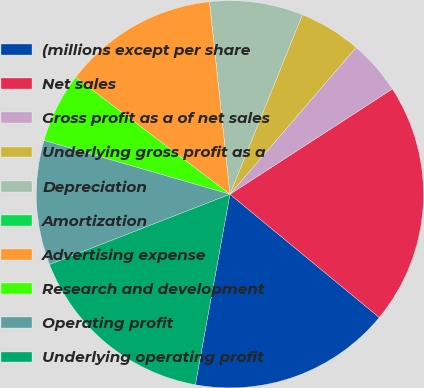Convert chart to OTSL. <chart><loc_0><loc_0><loc_500><loc_500><pie_chart><fcel>(millions except per share<fcel>Net sales<fcel>Gross profit as a of net sales<fcel>Underlying gross profit as a<fcel>Depreciation<fcel>Amortization<fcel>Advertising expense<fcel>Research and development<fcel>Operating profit<fcel>Underlying operating profit<nl><fcel>16.88%<fcel>20.13%<fcel>4.55%<fcel>5.19%<fcel>7.79%<fcel>0.0%<fcel>12.99%<fcel>5.84%<fcel>10.39%<fcel>16.23%<nl></chart> 